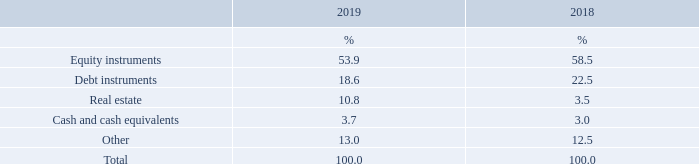The average duration of the defined benefit obligation at the end of the reporting period is 6.8 years (2018: 6.3 years) which relates wholly to active participants.
The plan invests entirely in pooled superannuation trust products where prices are quoted daily. The asset allocation of the plan has been set taking into account the membership profile, the liquidity requirements of the plan, and risk appetite of the Group.
The percentage invested in each asset class is as follows:
What factors are taken into consideration when setting the asset allocation of the plan? The membership profile, the liquidity requirements of the plan, and risk appetite of the group. What is the average duration of the defined benefit obligation at the end of the reporting period? 6.8 years. What does the plan invests in? Pooled superannuation trust products where prices are quoted daily. What is the difference in equity instruments between 2018 and 2019?
Answer scale should be: percent. 58.5% - 53.9% 
Answer: 4.6. What is the average percentage constitution of real estate for 2018 and 2019?
Answer scale should be: percent. (10.8% + 3.5%)/2 
Answer: 7.15. What is the difference in debt instruments between 2018 and 2019?
Answer scale should be: percent. 22.5% - 18.6% 
Answer: 3.9. 